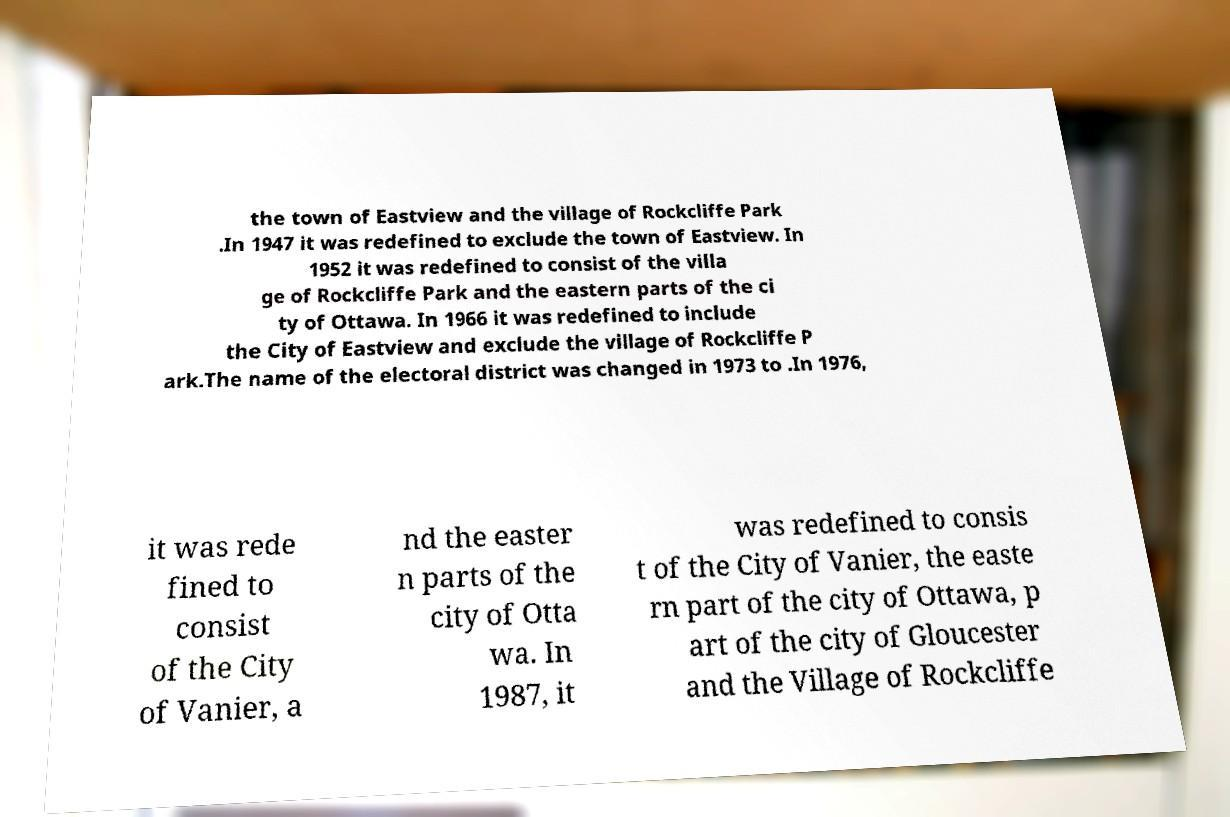What messages or text are displayed in this image? I need them in a readable, typed format. the town of Eastview and the village of Rockcliffe Park .In 1947 it was redefined to exclude the town of Eastview. In 1952 it was redefined to consist of the villa ge of Rockcliffe Park and the eastern parts of the ci ty of Ottawa. In 1966 it was redefined to include the City of Eastview and exclude the village of Rockcliffe P ark.The name of the electoral district was changed in 1973 to .In 1976, it was rede fined to consist of the City of Vanier, a nd the easter n parts of the city of Otta wa. In 1987, it was redefined to consis t of the City of Vanier, the easte rn part of the city of Ottawa, p art of the city of Gloucester and the Village of Rockcliffe 